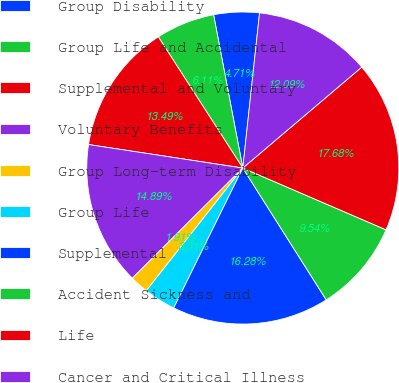Convert chart. <chart><loc_0><loc_0><loc_500><loc_500><pie_chart><fcel>Group Disability<fcel>Group Life and Accidental<fcel>Supplemental and Voluntary<fcel>Voluntary Benefits<fcel>Group Long-term Disability<fcel>Group Life<fcel>Supplemental<fcel>Accident Sickness and<fcel>Life<fcel>Cancer and Critical Illness<nl><fcel>4.71%<fcel>6.11%<fcel>13.49%<fcel>14.89%<fcel>1.91%<fcel>3.31%<fcel>16.28%<fcel>9.54%<fcel>17.68%<fcel>12.09%<nl></chart> 